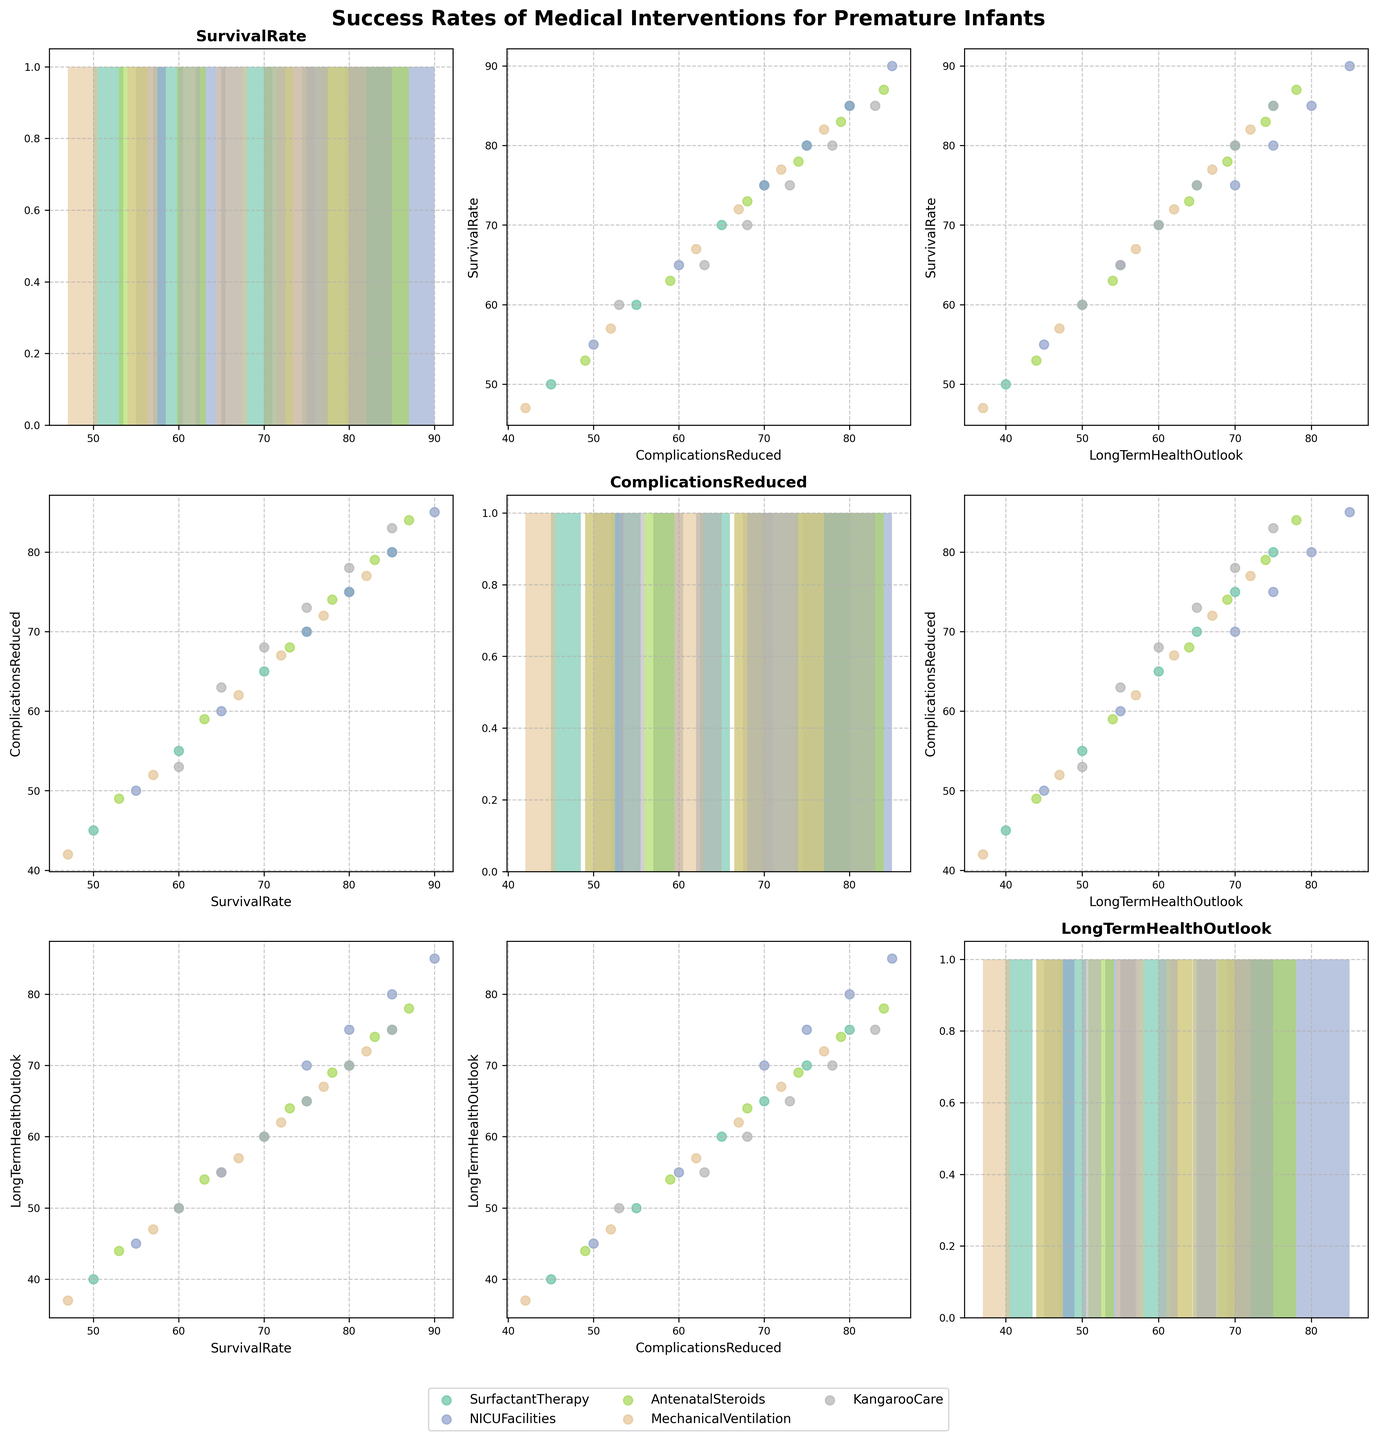What is the title of the plot? The title is located at the top center of the figure and provides a summary of the plot's content. In this case, it should be a general statement about the figure.
Answer: Success Rates of Medical Interventions for Premature Infants How many interventions are represented by different colors in the plot? Each intervention is uniquely color-coded. By counting the distinct colors used, you can determine the number of interventions.
Answer: 5 Which intervention shows the highest survival rate over time? By checking the scatter plots and looking for the highest points on the survival rate axis, we can identify the intervention with the highest values.
Answer: NICU Facilities What is the relationship between Complications Reduced and Long-Term Health Outlook for Antenatal Steroids? Locate the scatter plot that compares Complications Reduced (x-axis) to Long-Term Health Outlook (y-axis) for Antenatal Steroids by looking at the respective sections of the matrix. Check the plotted data points for Antenatal Steroids.
Answer: Positive Relationship What pattern is observed in the histogram for Long-Term Health Outlook for Kangaroo Care? Identify the histogram corresponding to Long-Term Health Outlook for Kangaroo Care and observe the distribution pattern of data points.
Answer: Uniform Distribution Which intervention has the greatest improvement in Long-Term Health Outlook from 1995 to 2020? Compare the histograms for Long-Term Health Outlook across all interventions. The histogram with the steepest increase indicates the greatest improvement.
Answer: NICU Facilities Are there any interventions where Survival Rate and Complications Reduced have a linear correlation? Look at the scatter plots comparing Survival Rate (y-axis) and Complications Reduced (x-axis) for all interventions. Check for a linear trend in any of these plots.
Answer: Yes, NICU Facilities What is the trend in Survival Rate for Mechanical Ventilation from 1995 to 2020? Find the histogram for Survival Rate corresponding to Mechanical Ventilation and observe how the values change over the years.
Answer: Increasing Trend Which intervention has the smallest relative difference between Survival Rate and Long-Term Health Outlook in 2020? Identify the scatter plots for each intervention with 2020 data points, and calculate the relative differences between Survival Rate (y-axis) and Long-Term Health Outlook (x-axis). The smallest difference is the answer.
Answer: Kangaroo Care 